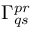<formula> <loc_0><loc_0><loc_500><loc_500>\Gamma _ { q s } ^ { p r }</formula> 